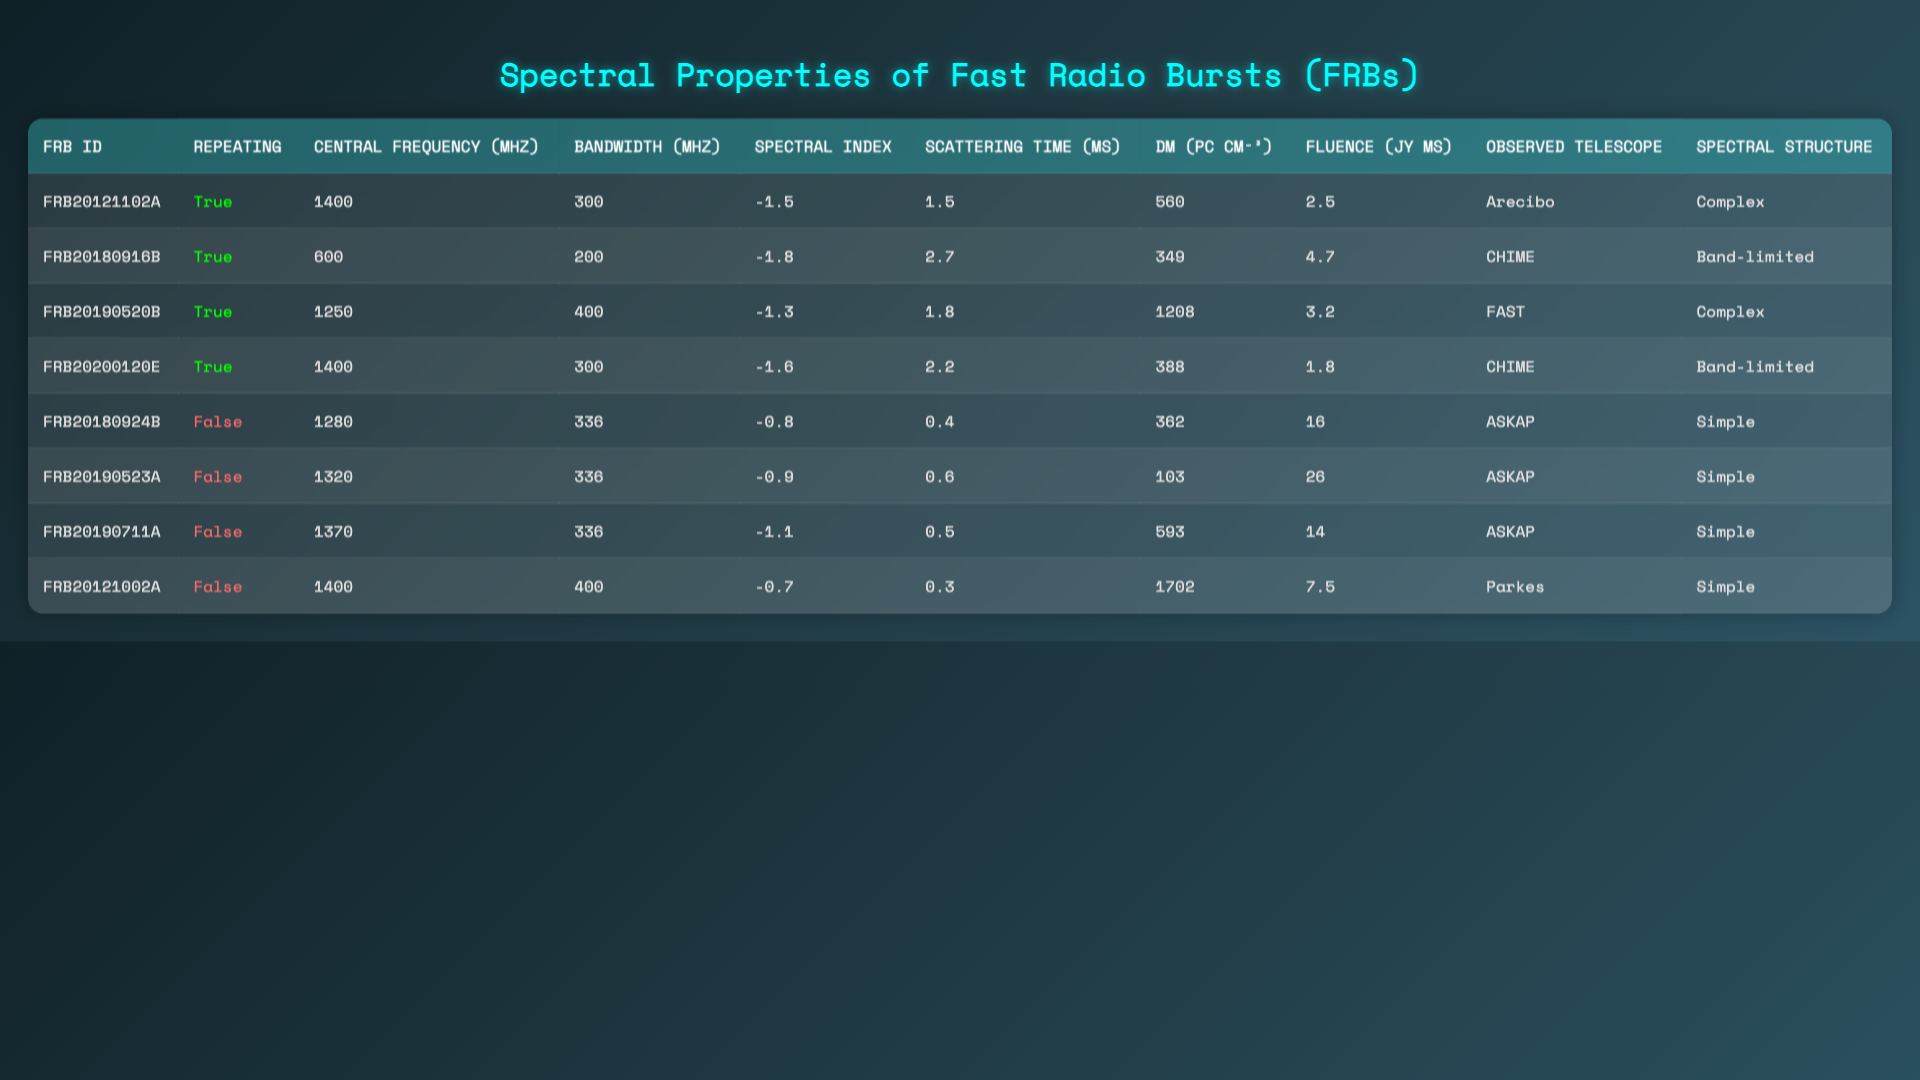How many FRBs in the table are classified as repeating? There are four entries in the "Repeating" column marked as true, indicating these FRBs are classified as repeating.
Answer: 4 What is the central frequency of FRB20180916B? From the "Central Frequency (MHz)" column, FRB20180916B has a central frequency of 600 MHz.
Answer: 600 MHz Is the DM value for FRB20190523A greater than 500 pc cm⁻³? The DM value for FRB20190523A is 103 pc cm⁻³, which is not greater than 500.
Answer: No Which FRB has the highest fluence value? The fluence values are compared, and FRB20180924B has the highest fluence at 16 Jy ms.
Answer: FRB20180924B What is the average spectral index of the repeating FRBs? The spectral indices of the repeating FRBs are -1.5, -1.8, -1.3, and -1.6. Summing these gives -6.2, and dividing by 4 yields an average of -1.55.
Answer: -1.55 Which telescope observed the FRB with the lowest scattering time? The scattering times are checked, and FRB20121002A has the lowest scattering time of 0.3 ms.
Answer: Parkes Is there a correlation between higher fluence and repeating nature? The repeating FRBs have fluence values of 2.5, 4.7, 3.2, and 1.8, while the non-repeating FRBs have values of 16, 26, 14, and 7.5. The average fluence for repeating FRBs is significantly lower than that for non-repeating ones. Therefore, no correlation supports a higher fluence for repeating FRBs.
Answer: No What is the difference in central frequency between the highest and the lowest central frequency FRBs? The highest central frequency is 1400 MHz (FRB20121102A and FRB20200120E) and the lowest is 600 MHz (FRB20180916B). The difference is 1400 - 600 = 800 MHz.
Answer: 800 MHz How does the spectral structure differ between repeating and non-repeating FRBs? The repeating FRBs have "Complex" and "Band-limited" spectral structures, while the non-repeating FRBs all show "Simple" spectral structure. Thus, the repeating ones exhibit more diversity in spectral structure.
Answer: Repeating: Complex & Band-limited; Non-repeating: Simple What is the total bandwidth of all repeating FRBs? The bandwidths of the repeating FRBs are 300, 200, 400, and 300 MHz. Adding them together results in 300 + 200 + 400 + 300 = 1200 MHz.
Answer: 1200 MHz 